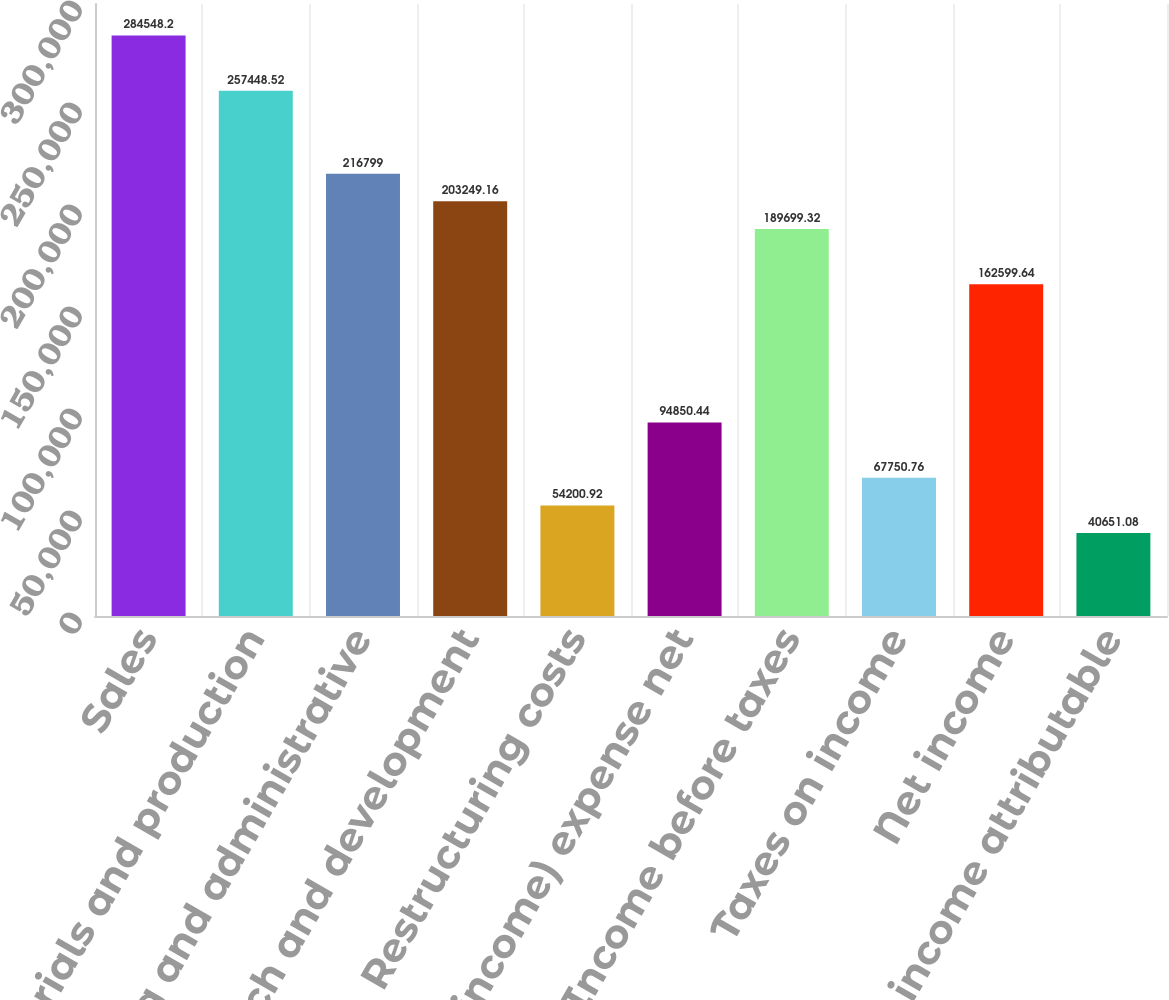Convert chart to OTSL. <chart><loc_0><loc_0><loc_500><loc_500><bar_chart><fcel>Sales<fcel>Materials and production<fcel>Marketing and administrative<fcel>Research and development<fcel>Restructuring costs<fcel>Other (income) expense net<fcel>Income before taxes<fcel>Taxes on income<fcel>Net income<fcel>Less Net income attributable<nl><fcel>284548<fcel>257449<fcel>216799<fcel>203249<fcel>54200.9<fcel>94850.4<fcel>189699<fcel>67750.8<fcel>162600<fcel>40651.1<nl></chart> 